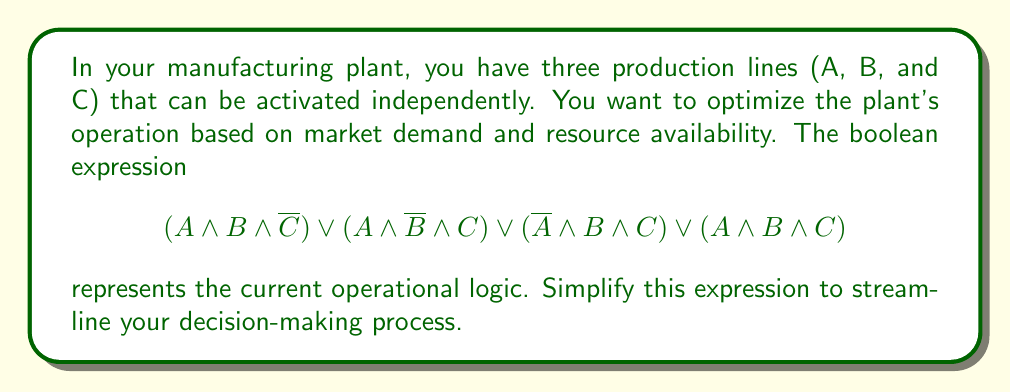Help me with this question. Let's simplify the expression step by step:

1) First, let's identify the given expression:
   $$(A \land B \land \overline{C}) \lor (A \land \overline{B} \land C) \lor (\overline{A} \land B \land C) \lor (A \land B \land C)$$

2) We can use the distributive law to factor out common terms. Notice that $A \land B$ appears in the first and last terms:
   $$(A \land B \land (\overline{C} \lor C)) \lor (A \land \overline{B} \land C) \lor (\overline{A} \land B \land C)$$

3) Simplify $\overline{C} \lor C$ to 1 (this is a tautology):
   $$(A \land B) \lor (A \land \overline{B} \land C) \lor (\overline{A} \land B \land C)$$

4) Now, we can factor out $C$ from the last two terms:
   $$(A \land B) \lor (C \land (A \land \overline{B} \lor \overline{A} \land B))$$

5) The expression $(A \land \overline{B} \lor \overline{A} \land B)$ is the exclusive OR of $A$ and $B$, which can be written as $A \oplus B$:
   $$(A \land B) \lor (C \land (A \oplus B))$$

6) This is our simplified expression. It means that the plant should operate when either:
   - Both A and B are active (regardless of C), or
   - C is active and exactly one of A or B is active (but not both)
Answer: $(A \land B) \lor (C \land (A \oplus B))$ 